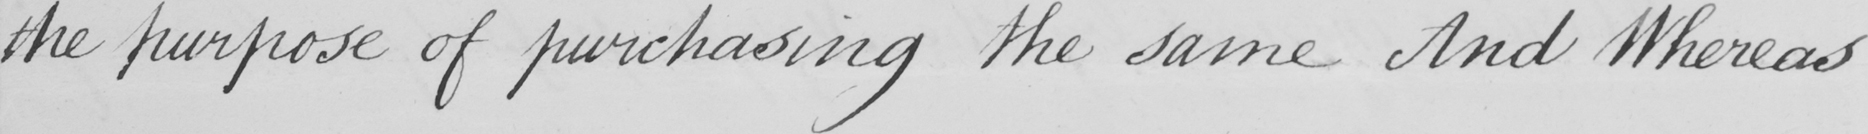What text is written in this handwritten line? the purpose of purchasing the same And Whereas 